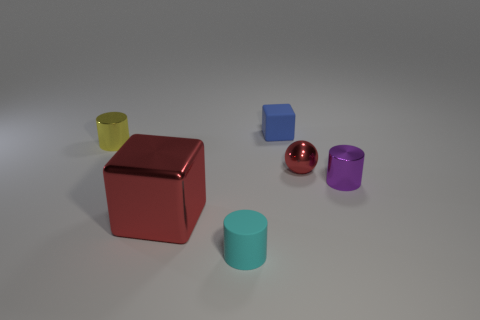Are there any other things that have the same size as the red shiny cube?
Ensure brevity in your answer.  No. What number of other things are there of the same color as the large cube?
Offer a terse response. 1. How big is the matte object in front of the cube behind the red object that is on the right side of the cyan matte cylinder?
Your answer should be compact. Small. There is a small cyan matte cylinder; are there any tiny cylinders behind it?
Provide a short and direct response. Yes. There is a yellow cylinder; does it have the same size as the matte object behind the red cube?
Keep it short and to the point. Yes. How many other things are the same material as the cyan cylinder?
Make the answer very short. 1. There is a object that is both left of the blue object and behind the small red ball; what shape is it?
Keep it short and to the point. Cylinder. Is the size of the shiny thing that is behind the small red ball the same as the cube to the right of the large red metal thing?
Provide a succinct answer. Yes. The big thing that is made of the same material as the tiny red thing is what shape?
Your answer should be compact. Cube. Is there any other thing that has the same shape as the small red metal object?
Provide a succinct answer. No. 